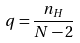<formula> <loc_0><loc_0><loc_500><loc_500>q = \frac { n _ { H } } { N - 2 }</formula> 